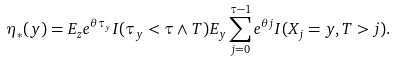Convert formula to latex. <formula><loc_0><loc_0><loc_500><loc_500>\eta _ { * } ( y ) = E _ { z } e ^ { \theta \tau _ { y } } I ( \tau _ { y } < \tau \wedge T ) E _ { y } \sum _ { j = 0 } ^ { \tau - 1 } e ^ { \theta j } I ( X _ { j } = y , T > j ) .</formula> 